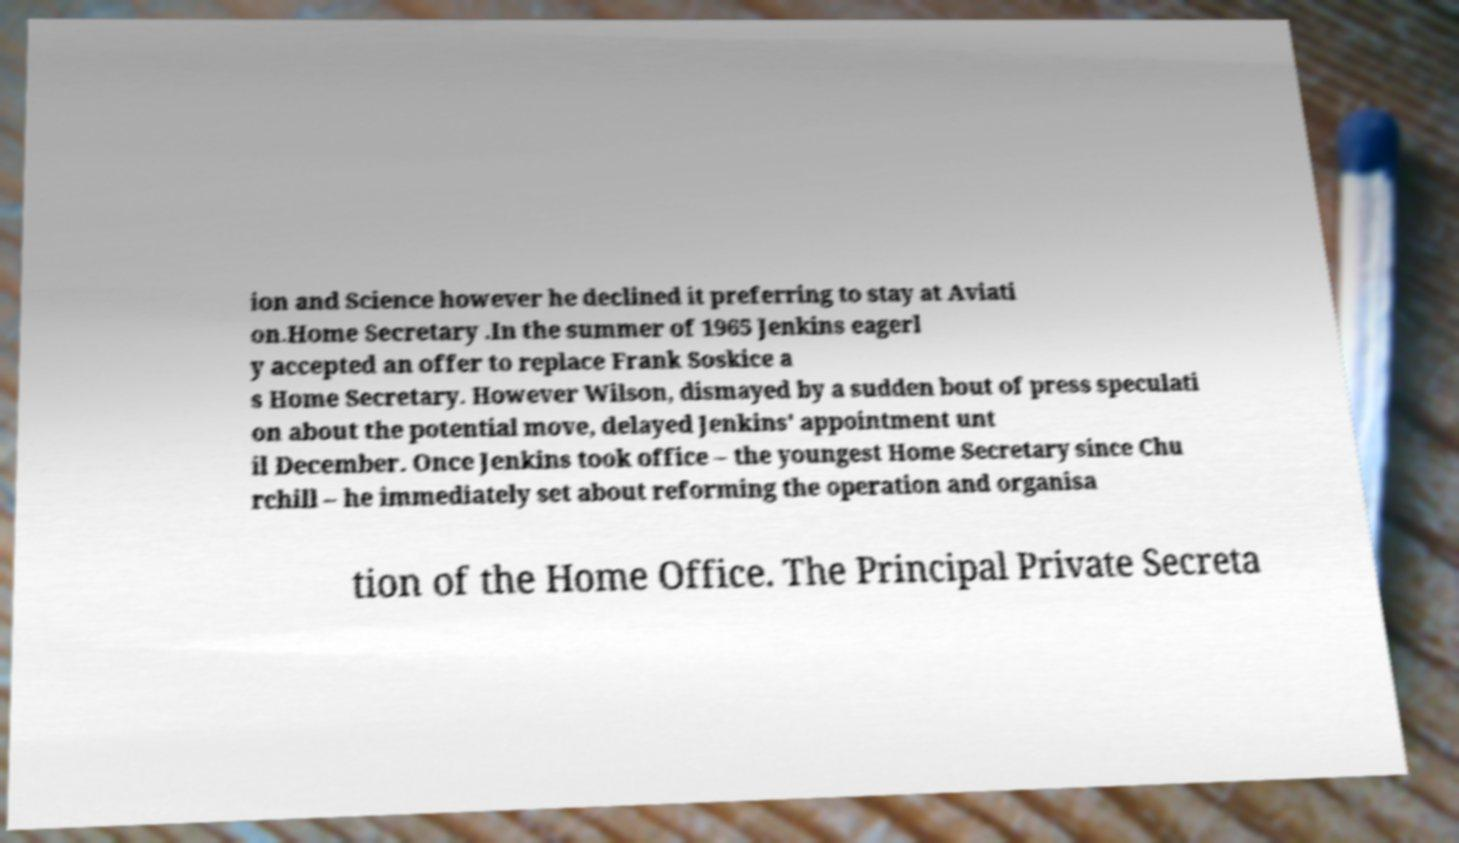I need the written content from this picture converted into text. Can you do that? ion and Science however he declined it preferring to stay at Aviati on.Home Secretary .In the summer of 1965 Jenkins eagerl y accepted an offer to replace Frank Soskice a s Home Secretary. However Wilson, dismayed by a sudden bout of press speculati on about the potential move, delayed Jenkins' appointment unt il December. Once Jenkins took office – the youngest Home Secretary since Chu rchill – he immediately set about reforming the operation and organisa tion of the Home Office. The Principal Private Secreta 